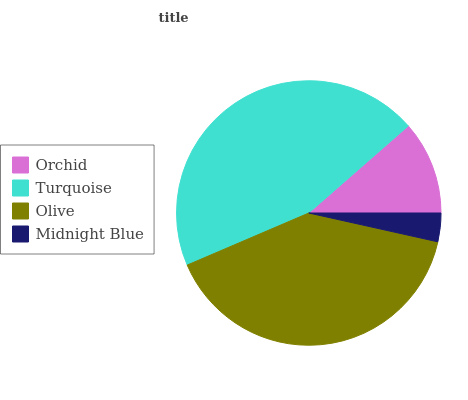Is Midnight Blue the minimum?
Answer yes or no. Yes. Is Turquoise the maximum?
Answer yes or no. Yes. Is Olive the minimum?
Answer yes or no. No. Is Olive the maximum?
Answer yes or no. No. Is Turquoise greater than Olive?
Answer yes or no. Yes. Is Olive less than Turquoise?
Answer yes or no. Yes. Is Olive greater than Turquoise?
Answer yes or no. No. Is Turquoise less than Olive?
Answer yes or no. No. Is Olive the high median?
Answer yes or no. Yes. Is Orchid the low median?
Answer yes or no. Yes. Is Turquoise the high median?
Answer yes or no. No. Is Olive the low median?
Answer yes or no. No. 